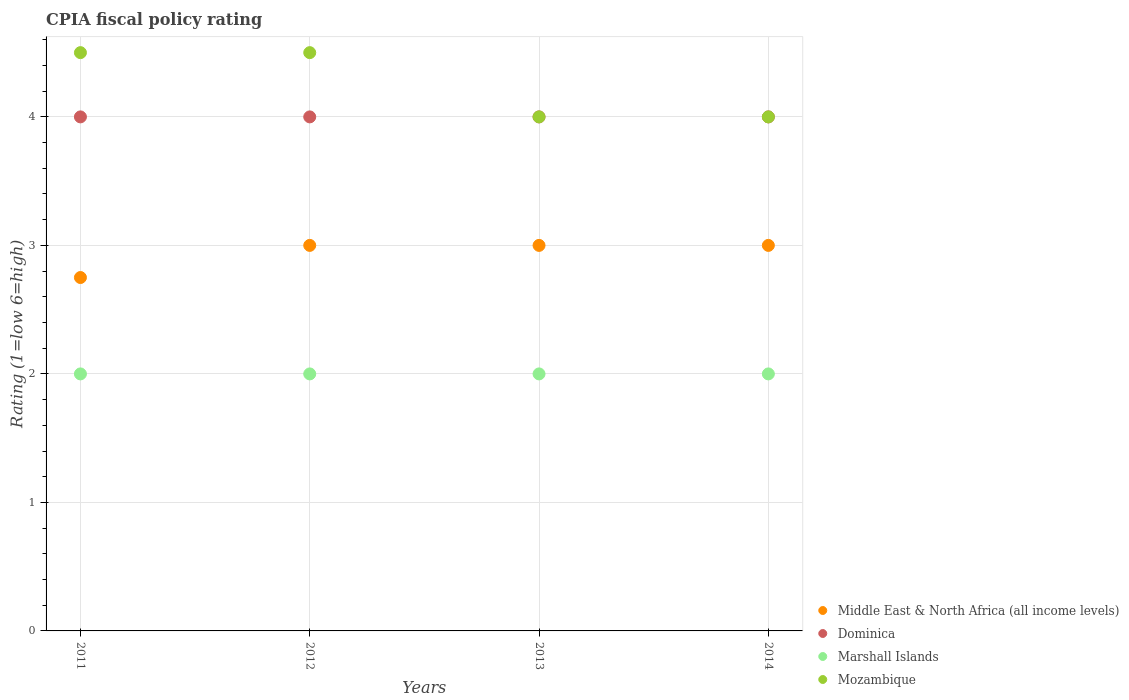How many different coloured dotlines are there?
Make the answer very short. 4. What is the CPIA rating in Dominica in 2011?
Your answer should be compact. 4. Across all years, what is the maximum CPIA rating in Dominica?
Keep it short and to the point. 4. Across all years, what is the minimum CPIA rating in Dominica?
Your answer should be compact. 4. In which year was the CPIA rating in Mozambique maximum?
Provide a short and direct response. 2011. In which year was the CPIA rating in Mozambique minimum?
Ensure brevity in your answer.  2013. What is the difference between the CPIA rating in Middle East & North Africa (all income levels) in 2011 and that in 2014?
Your response must be concise. -0.25. What is the average CPIA rating in Marshall Islands per year?
Your response must be concise. 2. In the year 2012, what is the difference between the CPIA rating in Dominica and CPIA rating in Marshall Islands?
Ensure brevity in your answer.  2. What is the difference between the highest and the second highest CPIA rating in Marshall Islands?
Keep it short and to the point. 0. Is it the case that in every year, the sum of the CPIA rating in Middle East & North Africa (all income levels) and CPIA rating in Marshall Islands  is greater than the CPIA rating in Dominica?
Keep it short and to the point. Yes. Does the CPIA rating in Dominica monotonically increase over the years?
Provide a succinct answer. No. How many dotlines are there?
Your response must be concise. 4. How many years are there in the graph?
Keep it short and to the point. 4. Are the values on the major ticks of Y-axis written in scientific E-notation?
Offer a very short reply. No. Does the graph contain grids?
Your answer should be very brief. Yes. How are the legend labels stacked?
Offer a very short reply. Vertical. What is the title of the graph?
Ensure brevity in your answer.  CPIA fiscal policy rating. Does "Fiji" appear as one of the legend labels in the graph?
Offer a very short reply. No. What is the label or title of the Y-axis?
Ensure brevity in your answer.  Rating (1=low 6=high). What is the Rating (1=low 6=high) in Middle East & North Africa (all income levels) in 2011?
Your response must be concise. 2.75. What is the Rating (1=low 6=high) in Dominica in 2011?
Offer a terse response. 4. What is the Rating (1=low 6=high) in Mozambique in 2011?
Your answer should be very brief. 4.5. What is the Rating (1=low 6=high) in Middle East & North Africa (all income levels) in 2013?
Offer a terse response. 3. What is the Rating (1=low 6=high) of Dominica in 2013?
Provide a short and direct response. 4. What is the Rating (1=low 6=high) of Marshall Islands in 2013?
Ensure brevity in your answer.  2. What is the Rating (1=low 6=high) in Mozambique in 2013?
Your answer should be compact. 4. What is the Rating (1=low 6=high) in Dominica in 2014?
Your answer should be compact. 4. Across all years, what is the maximum Rating (1=low 6=high) of Dominica?
Make the answer very short. 4. Across all years, what is the maximum Rating (1=low 6=high) of Marshall Islands?
Make the answer very short. 2. Across all years, what is the minimum Rating (1=low 6=high) in Middle East & North Africa (all income levels)?
Your response must be concise. 2.75. What is the total Rating (1=low 6=high) in Middle East & North Africa (all income levels) in the graph?
Your answer should be compact. 11.75. What is the total Rating (1=low 6=high) of Marshall Islands in the graph?
Offer a terse response. 8. What is the total Rating (1=low 6=high) of Mozambique in the graph?
Ensure brevity in your answer.  17. What is the difference between the Rating (1=low 6=high) of Marshall Islands in 2011 and that in 2012?
Give a very brief answer. 0. What is the difference between the Rating (1=low 6=high) of Mozambique in 2011 and that in 2012?
Your response must be concise. 0. What is the difference between the Rating (1=low 6=high) in Dominica in 2011 and that in 2013?
Your answer should be compact. 0. What is the difference between the Rating (1=low 6=high) of Marshall Islands in 2011 and that in 2014?
Your response must be concise. 0. What is the difference between the Rating (1=low 6=high) of Dominica in 2012 and that in 2013?
Offer a very short reply. 0. What is the difference between the Rating (1=low 6=high) of Marshall Islands in 2012 and that in 2013?
Make the answer very short. 0. What is the difference between the Rating (1=low 6=high) of Mozambique in 2012 and that in 2013?
Give a very brief answer. 0.5. What is the difference between the Rating (1=low 6=high) in Marshall Islands in 2012 and that in 2014?
Make the answer very short. 0. What is the difference between the Rating (1=low 6=high) of Mozambique in 2012 and that in 2014?
Provide a succinct answer. 0.5. What is the difference between the Rating (1=low 6=high) of Middle East & North Africa (all income levels) in 2013 and that in 2014?
Offer a very short reply. 0. What is the difference between the Rating (1=low 6=high) in Marshall Islands in 2013 and that in 2014?
Keep it short and to the point. 0. What is the difference between the Rating (1=low 6=high) in Mozambique in 2013 and that in 2014?
Give a very brief answer. 0. What is the difference between the Rating (1=low 6=high) of Middle East & North Africa (all income levels) in 2011 and the Rating (1=low 6=high) of Dominica in 2012?
Your answer should be compact. -1.25. What is the difference between the Rating (1=low 6=high) in Middle East & North Africa (all income levels) in 2011 and the Rating (1=low 6=high) in Mozambique in 2012?
Offer a terse response. -1.75. What is the difference between the Rating (1=low 6=high) of Marshall Islands in 2011 and the Rating (1=low 6=high) of Mozambique in 2012?
Give a very brief answer. -2.5. What is the difference between the Rating (1=low 6=high) of Middle East & North Africa (all income levels) in 2011 and the Rating (1=low 6=high) of Dominica in 2013?
Provide a short and direct response. -1.25. What is the difference between the Rating (1=low 6=high) of Middle East & North Africa (all income levels) in 2011 and the Rating (1=low 6=high) of Mozambique in 2013?
Offer a terse response. -1.25. What is the difference between the Rating (1=low 6=high) of Dominica in 2011 and the Rating (1=low 6=high) of Marshall Islands in 2013?
Give a very brief answer. 2. What is the difference between the Rating (1=low 6=high) of Marshall Islands in 2011 and the Rating (1=low 6=high) of Mozambique in 2013?
Give a very brief answer. -2. What is the difference between the Rating (1=low 6=high) of Middle East & North Africa (all income levels) in 2011 and the Rating (1=low 6=high) of Dominica in 2014?
Your answer should be very brief. -1.25. What is the difference between the Rating (1=low 6=high) of Middle East & North Africa (all income levels) in 2011 and the Rating (1=low 6=high) of Mozambique in 2014?
Provide a short and direct response. -1.25. What is the difference between the Rating (1=low 6=high) in Middle East & North Africa (all income levels) in 2012 and the Rating (1=low 6=high) in Dominica in 2013?
Provide a short and direct response. -1. What is the difference between the Rating (1=low 6=high) of Dominica in 2012 and the Rating (1=low 6=high) of Mozambique in 2013?
Give a very brief answer. 0. What is the difference between the Rating (1=low 6=high) of Marshall Islands in 2012 and the Rating (1=low 6=high) of Mozambique in 2013?
Provide a short and direct response. -2. What is the difference between the Rating (1=low 6=high) in Middle East & North Africa (all income levels) in 2012 and the Rating (1=low 6=high) in Dominica in 2014?
Your answer should be compact. -1. What is the difference between the Rating (1=low 6=high) of Middle East & North Africa (all income levels) in 2012 and the Rating (1=low 6=high) of Marshall Islands in 2014?
Ensure brevity in your answer.  1. What is the difference between the Rating (1=low 6=high) in Dominica in 2012 and the Rating (1=low 6=high) in Marshall Islands in 2014?
Your answer should be very brief. 2. What is the difference between the Rating (1=low 6=high) in Dominica in 2012 and the Rating (1=low 6=high) in Mozambique in 2014?
Offer a very short reply. 0. What is the difference between the Rating (1=low 6=high) in Middle East & North Africa (all income levels) in 2013 and the Rating (1=low 6=high) in Dominica in 2014?
Ensure brevity in your answer.  -1. What is the difference between the Rating (1=low 6=high) of Middle East & North Africa (all income levels) in 2013 and the Rating (1=low 6=high) of Mozambique in 2014?
Make the answer very short. -1. What is the difference between the Rating (1=low 6=high) of Dominica in 2013 and the Rating (1=low 6=high) of Marshall Islands in 2014?
Offer a terse response. 2. What is the difference between the Rating (1=low 6=high) of Dominica in 2013 and the Rating (1=low 6=high) of Mozambique in 2014?
Offer a very short reply. 0. What is the average Rating (1=low 6=high) in Middle East & North Africa (all income levels) per year?
Offer a very short reply. 2.94. What is the average Rating (1=low 6=high) of Mozambique per year?
Ensure brevity in your answer.  4.25. In the year 2011, what is the difference between the Rating (1=low 6=high) in Middle East & North Africa (all income levels) and Rating (1=low 6=high) in Dominica?
Keep it short and to the point. -1.25. In the year 2011, what is the difference between the Rating (1=low 6=high) of Middle East & North Africa (all income levels) and Rating (1=low 6=high) of Mozambique?
Ensure brevity in your answer.  -1.75. In the year 2011, what is the difference between the Rating (1=low 6=high) in Dominica and Rating (1=low 6=high) in Mozambique?
Provide a short and direct response. -0.5. In the year 2011, what is the difference between the Rating (1=low 6=high) of Marshall Islands and Rating (1=low 6=high) of Mozambique?
Your answer should be very brief. -2.5. In the year 2012, what is the difference between the Rating (1=low 6=high) in Middle East & North Africa (all income levels) and Rating (1=low 6=high) in Marshall Islands?
Your answer should be very brief. 1. In the year 2012, what is the difference between the Rating (1=low 6=high) in Middle East & North Africa (all income levels) and Rating (1=low 6=high) in Mozambique?
Give a very brief answer. -1.5. In the year 2012, what is the difference between the Rating (1=low 6=high) in Dominica and Rating (1=low 6=high) in Marshall Islands?
Provide a short and direct response. 2. In the year 2012, what is the difference between the Rating (1=low 6=high) in Dominica and Rating (1=low 6=high) in Mozambique?
Your response must be concise. -0.5. In the year 2013, what is the difference between the Rating (1=low 6=high) in Middle East & North Africa (all income levels) and Rating (1=low 6=high) in Mozambique?
Provide a succinct answer. -1. In the year 2013, what is the difference between the Rating (1=low 6=high) in Marshall Islands and Rating (1=low 6=high) in Mozambique?
Your answer should be compact. -2. In the year 2014, what is the difference between the Rating (1=low 6=high) in Dominica and Rating (1=low 6=high) in Marshall Islands?
Offer a very short reply. 2. In the year 2014, what is the difference between the Rating (1=low 6=high) of Marshall Islands and Rating (1=low 6=high) of Mozambique?
Keep it short and to the point. -2. What is the ratio of the Rating (1=low 6=high) in Dominica in 2011 to that in 2012?
Give a very brief answer. 1. What is the ratio of the Rating (1=low 6=high) of Marshall Islands in 2011 to that in 2012?
Provide a short and direct response. 1. What is the ratio of the Rating (1=low 6=high) of Mozambique in 2011 to that in 2012?
Provide a short and direct response. 1. What is the ratio of the Rating (1=low 6=high) of Middle East & North Africa (all income levels) in 2011 to that in 2013?
Provide a succinct answer. 0.92. What is the ratio of the Rating (1=low 6=high) in Dominica in 2011 to that in 2013?
Provide a succinct answer. 1. What is the ratio of the Rating (1=low 6=high) in Marshall Islands in 2011 to that in 2013?
Your response must be concise. 1. What is the ratio of the Rating (1=low 6=high) in Mozambique in 2011 to that in 2013?
Your response must be concise. 1.12. What is the ratio of the Rating (1=low 6=high) in Middle East & North Africa (all income levels) in 2011 to that in 2014?
Your response must be concise. 0.92. What is the ratio of the Rating (1=low 6=high) of Dominica in 2011 to that in 2014?
Make the answer very short. 1. What is the ratio of the Rating (1=low 6=high) in Middle East & North Africa (all income levels) in 2012 to that in 2014?
Make the answer very short. 1. What is the ratio of the Rating (1=low 6=high) in Mozambique in 2012 to that in 2014?
Offer a terse response. 1.12. What is the difference between the highest and the second highest Rating (1=low 6=high) of Marshall Islands?
Your answer should be compact. 0. What is the difference between the highest and the lowest Rating (1=low 6=high) in Dominica?
Offer a very short reply. 0. What is the difference between the highest and the lowest Rating (1=low 6=high) of Marshall Islands?
Keep it short and to the point. 0. What is the difference between the highest and the lowest Rating (1=low 6=high) of Mozambique?
Provide a succinct answer. 0.5. 